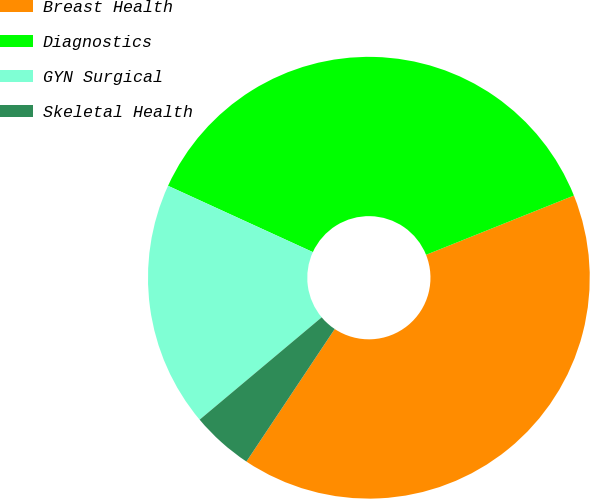Convert chart. <chart><loc_0><loc_0><loc_500><loc_500><pie_chart><fcel>Breast Health<fcel>Diagnostics<fcel>GYN Surgical<fcel>Skeletal Health<nl><fcel>40.42%<fcel>37.1%<fcel>17.94%<fcel>4.54%<nl></chart> 